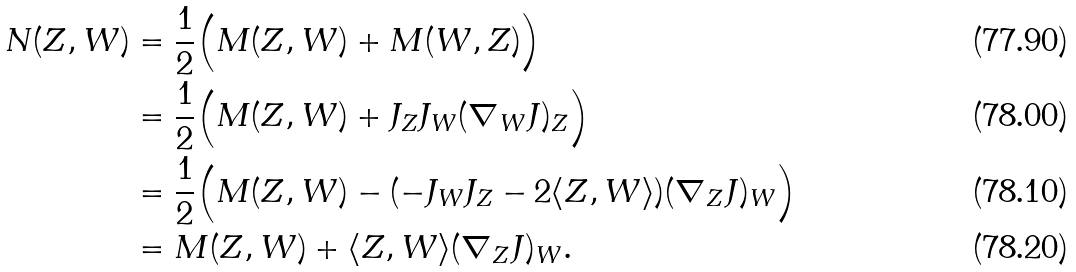<formula> <loc_0><loc_0><loc_500><loc_500>N ( Z , W ) & = \frac { 1 } { 2 } \Big { ( } M ( Z , W ) + M ( W , Z ) \Big { ) } \\ & = \frac { 1 } { 2 } \Big { ( } M ( Z , W ) + J _ { Z } J _ { W } ( \nabla _ { W } J ) _ { Z } \Big { ) } \\ & = \frac { 1 } { 2 } \Big { ( } M ( Z , W ) - ( - J _ { W } J _ { Z } - 2 \langle Z , W \rangle ) ( \nabla _ { Z } J ) _ { W } \Big { ) } \\ & = M ( Z , W ) + \langle Z , W \rangle ( \nabla _ { Z } J ) _ { W } .</formula> 